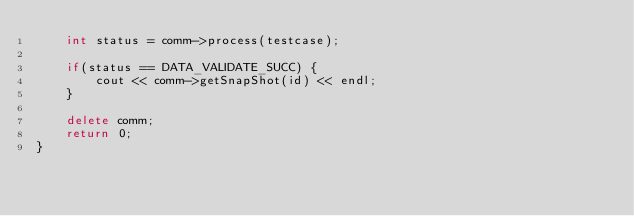Convert code to text. <code><loc_0><loc_0><loc_500><loc_500><_C++_>    int status = comm->process(testcase);

    if(status == DATA_VALIDATE_SUCC) {
        cout << comm->getSnapShot(id) << endl;
    }

    delete comm;
    return 0;
}
</code> 